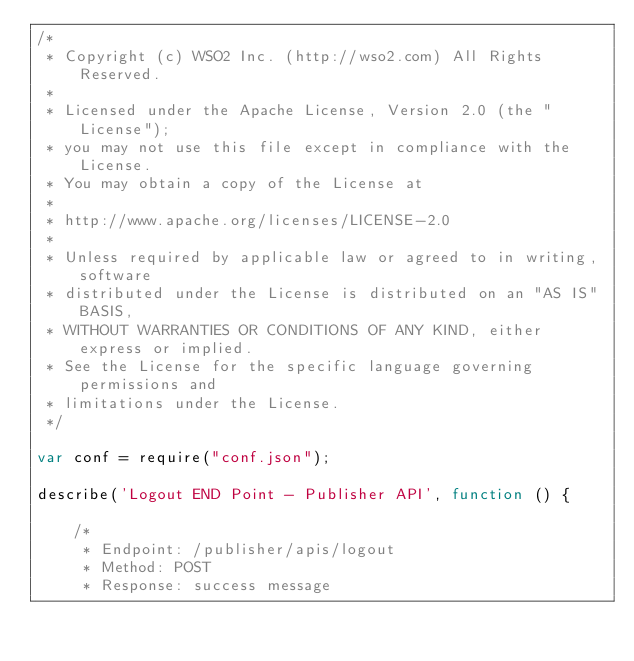<code> <loc_0><loc_0><loc_500><loc_500><_JavaScript_>/*
 * Copyright (c) WSO2 Inc. (http://wso2.com) All Rights Reserved.
 *
 * Licensed under the Apache License, Version 2.0 (the "License");
 * you may not use this file except in compliance with the License.
 * You may obtain a copy of the License at
 *
 * http://www.apache.org/licenses/LICENSE-2.0
 *
 * Unless required by applicable law or agreed to in writing, software
 * distributed under the License is distributed on an "AS IS" BASIS,
 * WITHOUT WARRANTIES OR CONDITIONS OF ANY KIND, either express or implied.
 * See the License for the specific language governing permissions and
 * limitations under the License.
 */

var conf = require("conf.json");

describe('Logout END Point - Publisher API', function () {

    /*
     * Endpoint: /publisher/apis/logout
     * Method: POST
     * Response: success message</code> 